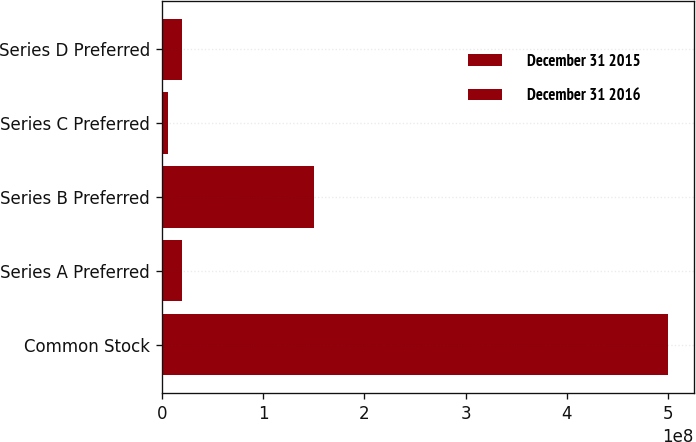Convert chart to OTSL. <chart><loc_0><loc_0><loc_500><loc_500><stacked_bar_chart><ecel><fcel>Common Stock<fcel>Series A Preferred<fcel>Series B Preferred<fcel>Series C Preferred<fcel>Series D Preferred<nl><fcel>December 31 2015<fcel>5e+08<fcel>2e+07<fcel>1.5e+08<fcel>6e+06<fcel>2e+07<nl><fcel>December 31 2016<fcel>5e+08<fcel>2e+07<fcel>1.5e+08<fcel>6e+06<fcel>2e+07<nl></chart> 